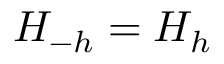Convert formula to latex. <formula><loc_0><loc_0><loc_500><loc_500>H _ { - h } = H _ { h }</formula> 